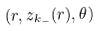Convert formula to latex. <formula><loc_0><loc_0><loc_500><loc_500>( r , z _ { k _ { - } } ( r ) , \theta )</formula> 